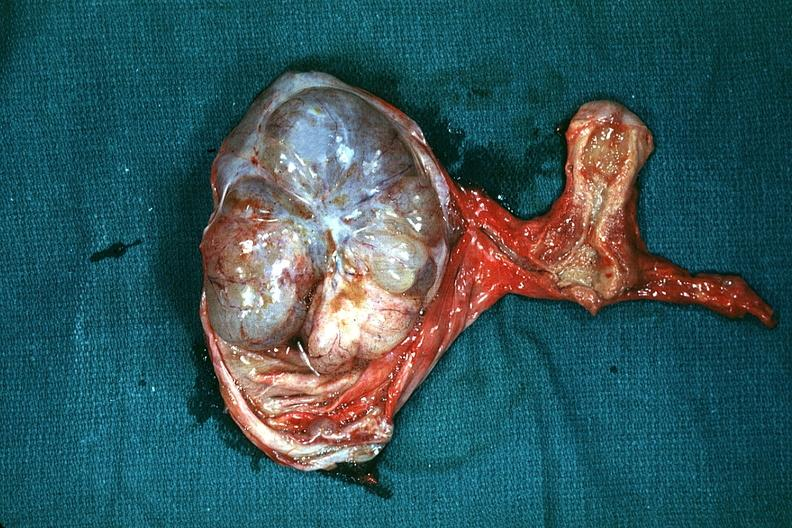s mucinous cystadenocarcinoma present?
Answer the question using a single word or phrase. Yes 